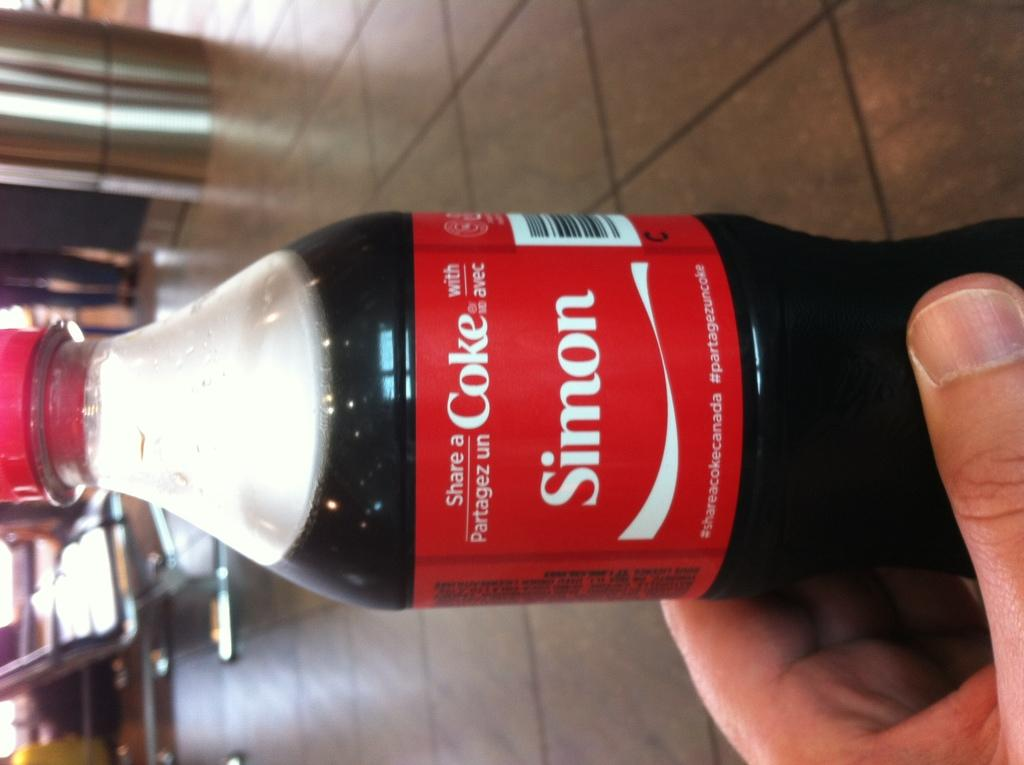<image>
Offer a succinct explanation of the picture presented. A person is holding a coke bottle that has the name Simon on it. 